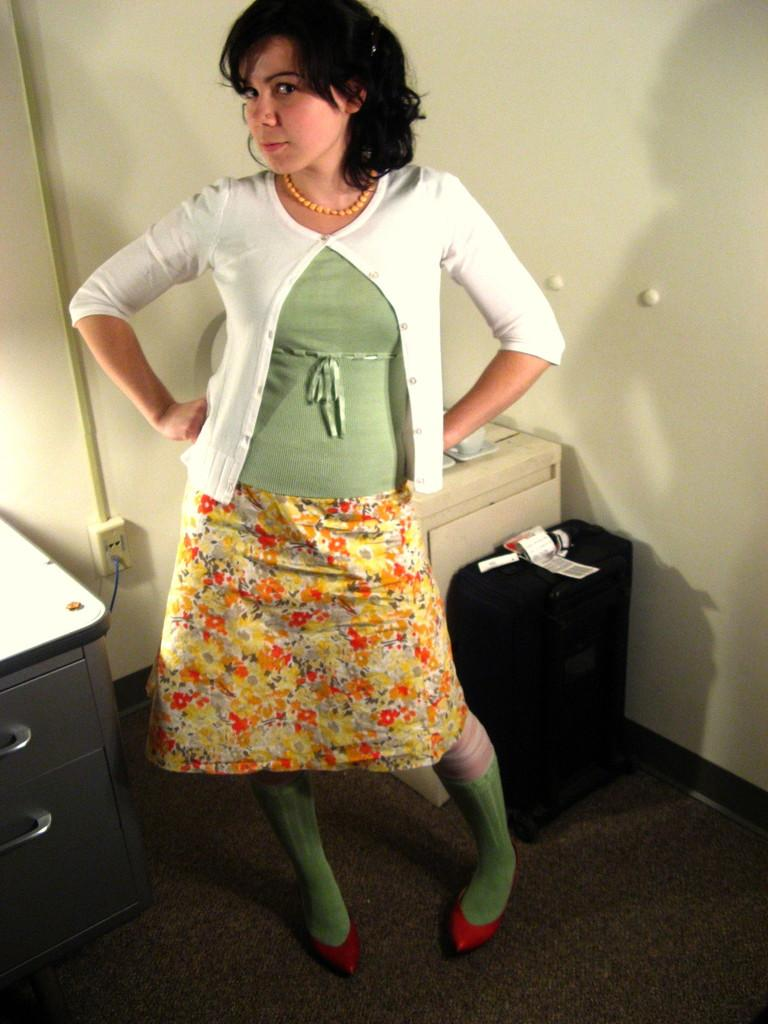What is the main subject of the image? There is a woman standing in the image. Where is the woman standing? The woman is standing on the floor. What can be seen in the background of the image? In the background of the image, there is a pipeline, a power notch, a cable, cupboards, walls, and a suitcase. What type of treatment is the woman receiving in the image? There is no indication in the image that the woman is receiving any treatment. Can you solve the riddle that is present in the image? There is no riddle present in the image. 